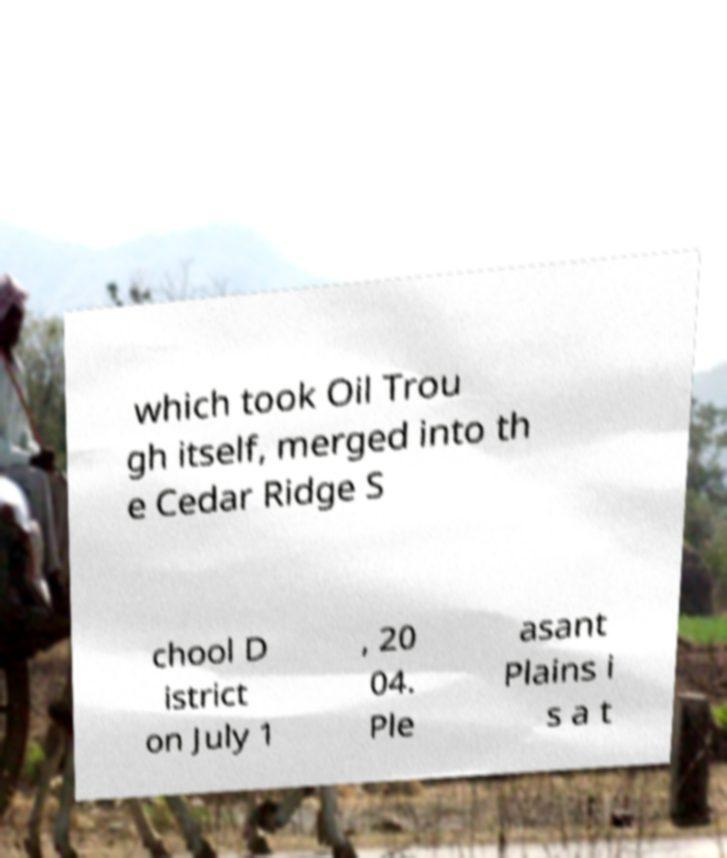Can you read and provide the text displayed in the image?This photo seems to have some interesting text. Can you extract and type it out for me? which took Oil Trou gh itself, merged into th e Cedar Ridge S chool D istrict on July 1 , 20 04. Ple asant Plains i s a t 